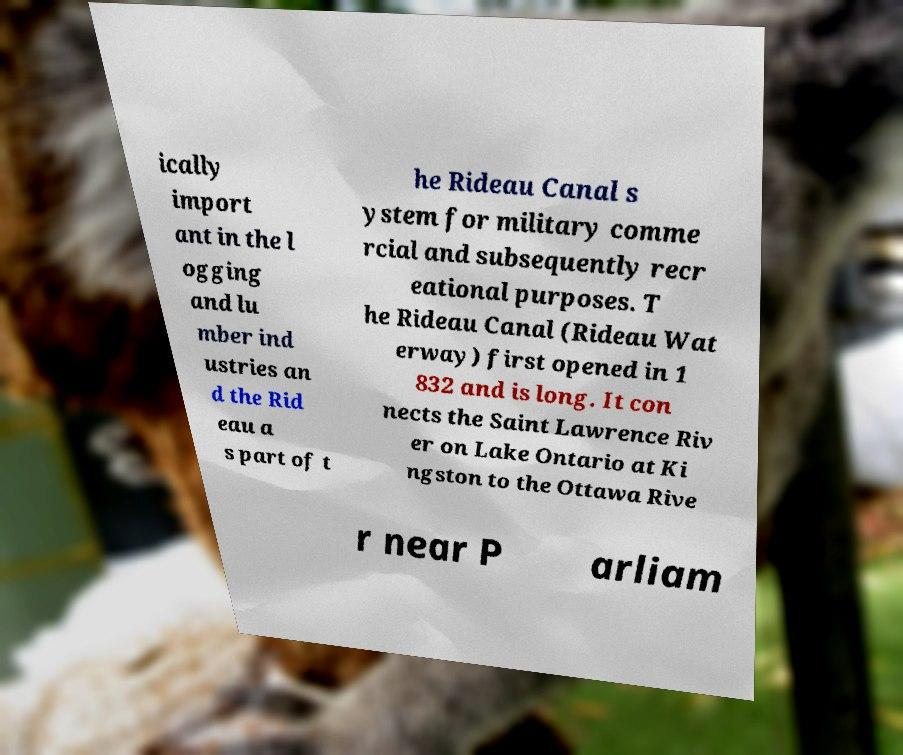Could you assist in decoding the text presented in this image and type it out clearly? ically import ant in the l ogging and lu mber ind ustries an d the Rid eau a s part of t he Rideau Canal s ystem for military comme rcial and subsequently recr eational purposes. T he Rideau Canal (Rideau Wat erway) first opened in 1 832 and is long. It con nects the Saint Lawrence Riv er on Lake Ontario at Ki ngston to the Ottawa Rive r near P arliam 